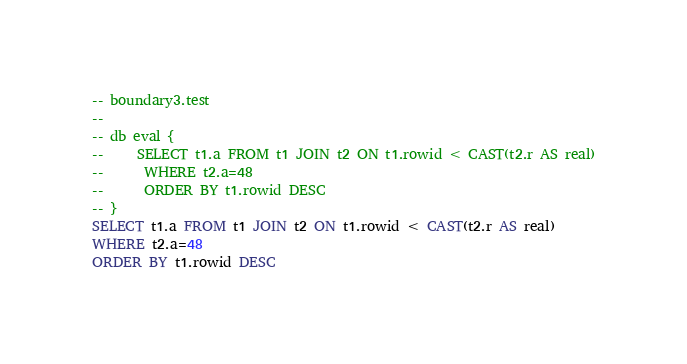<code> <loc_0><loc_0><loc_500><loc_500><_SQL_>-- boundary3.test
-- 
-- db eval {
--     SELECT t1.a FROM t1 JOIN t2 ON t1.rowid < CAST(t2.r AS real)
--      WHERE t2.a=48
--      ORDER BY t1.rowid DESC
-- }
SELECT t1.a FROM t1 JOIN t2 ON t1.rowid < CAST(t2.r AS real)
WHERE t2.a=48
ORDER BY t1.rowid DESC</code> 